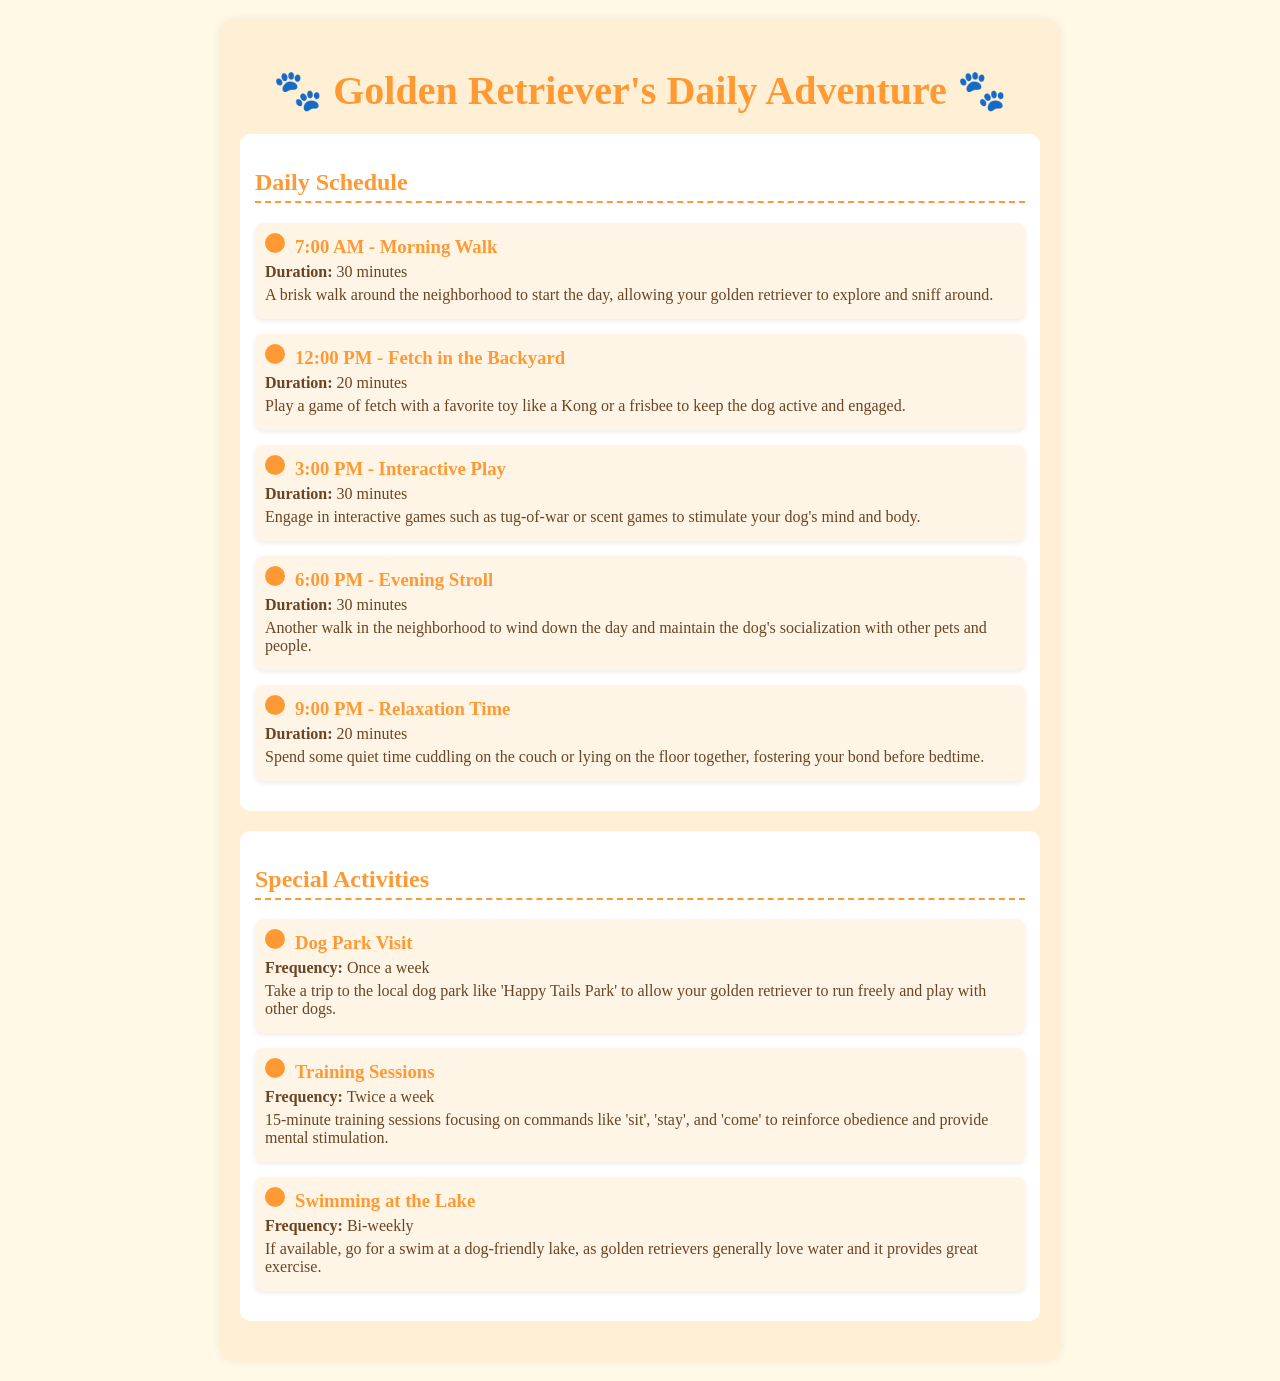what time is the morning walk scheduled? The morning walk is listed as starting at 7:00 AM in the schedule.
Answer: 7:00 AM what is the duration of the evening stroll? The schedule indicates that the evening stroll lasts for 30 minutes.
Answer: 30 minutes how often are training sessions scheduled? The document states that training sessions occur twice a week.
Answer: Twice a week what activity is suggested after the midday fetch? The next activity after fetch in the backyard is interactive play at 3:00 PM.
Answer: Interactive play what special activity is mentioned for swimming? The schedule includes swimming at the lake as a bi-weekly activity.
Answer: Bi-weekly what is the purpose of the 9:00 PM relaxation time? The relaxation time aims to foster the bond between the dog and the caregiver before bedtime.
Answer: Foster bond how long is the fetching activity in the backyard? Fetch in the backyard lasts for 20 minutes according to the schedule.
Answer: 20 minutes where is the dog park visit suggested to take place? The document references a local dog park named 'Happy Tails Park' for the visit.
Answer: Happy Tails Park 